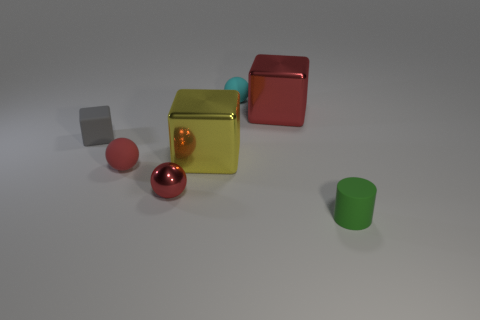Add 3 cylinders. How many objects exist? 10 Subtract all cylinders. How many objects are left? 6 Subtract all big cyan blocks. Subtract all tiny rubber cylinders. How many objects are left? 6 Add 7 small cubes. How many small cubes are left? 8 Add 6 gray cylinders. How many gray cylinders exist? 6 Subtract 1 green cylinders. How many objects are left? 6 